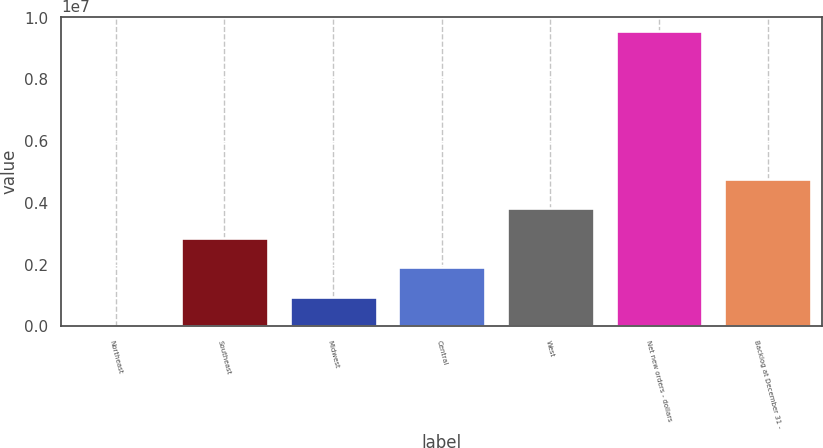Convert chart. <chart><loc_0><loc_0><loc_500><loc_500><bar_chart><fcel>Northeast<fcel>Southeast<fcel>Midwest<fcel>Central<fcel>West<fcel>Net new orders - dollars<fcel>Backlog at December 31 -<nl><fcel>2692<fcel>2.86838e+06<fcel>957923<fcel>1.91315e+06<fcel>3.82362e+06<fcel>9.555e+06<fcel>4.77885e+06<nl></chart> 